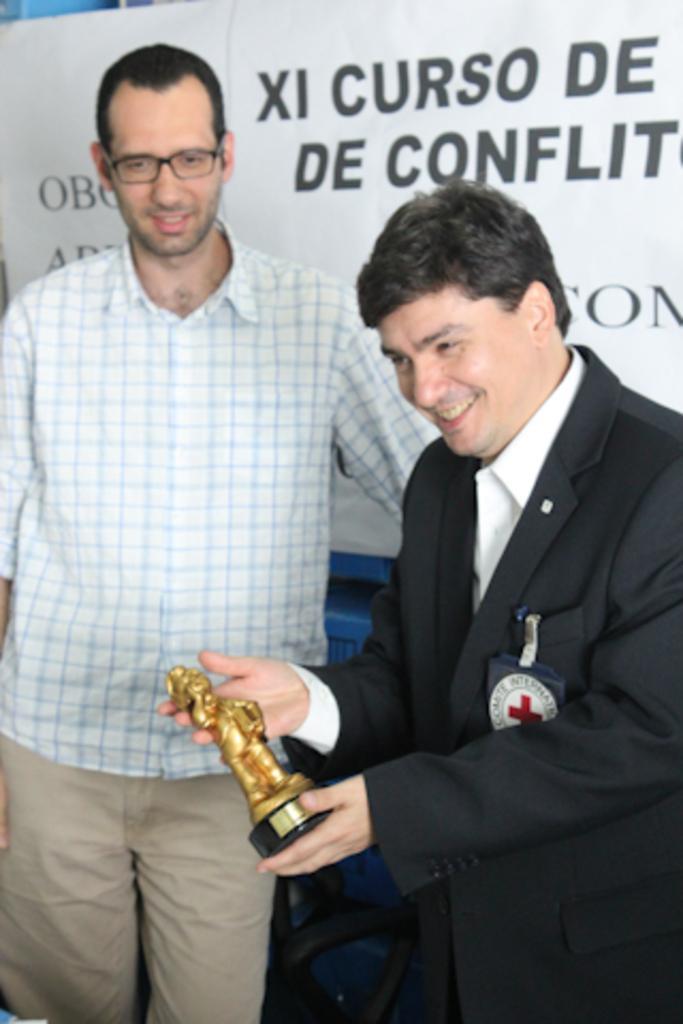Please provide a concise description of this image. In the picture we can see two men are standing, one is with shirt and trouser and one man is with blazer, tie and shirt and holding a small idol which is gold in color and he is smiling and behind them we can see a banner which is white in color with some information in it. 